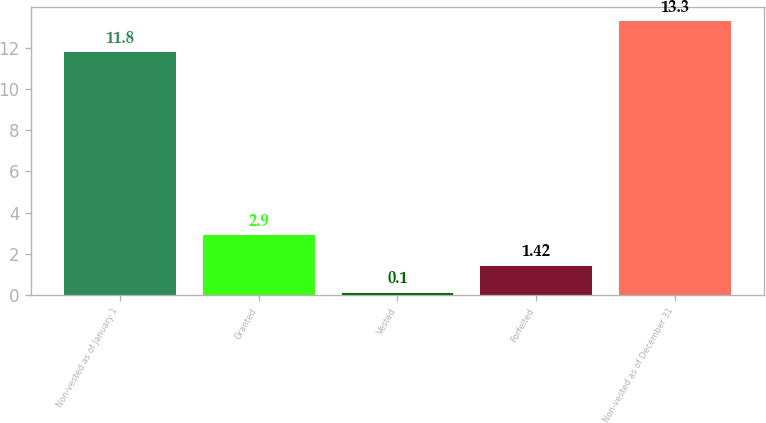<chart> <loc_0><loc_0><loc_500><loc_500><bar_chart><fcel>Non-vested as of January 1<fcel>Granted<fcel>Vested<fcel>Forfeited<fcel>Non-vested as of December 31<nl><fcel>11.8<fcel>2.9<fcel>0.1<fcel>1.42<fcel>13.3<nl></chart> 